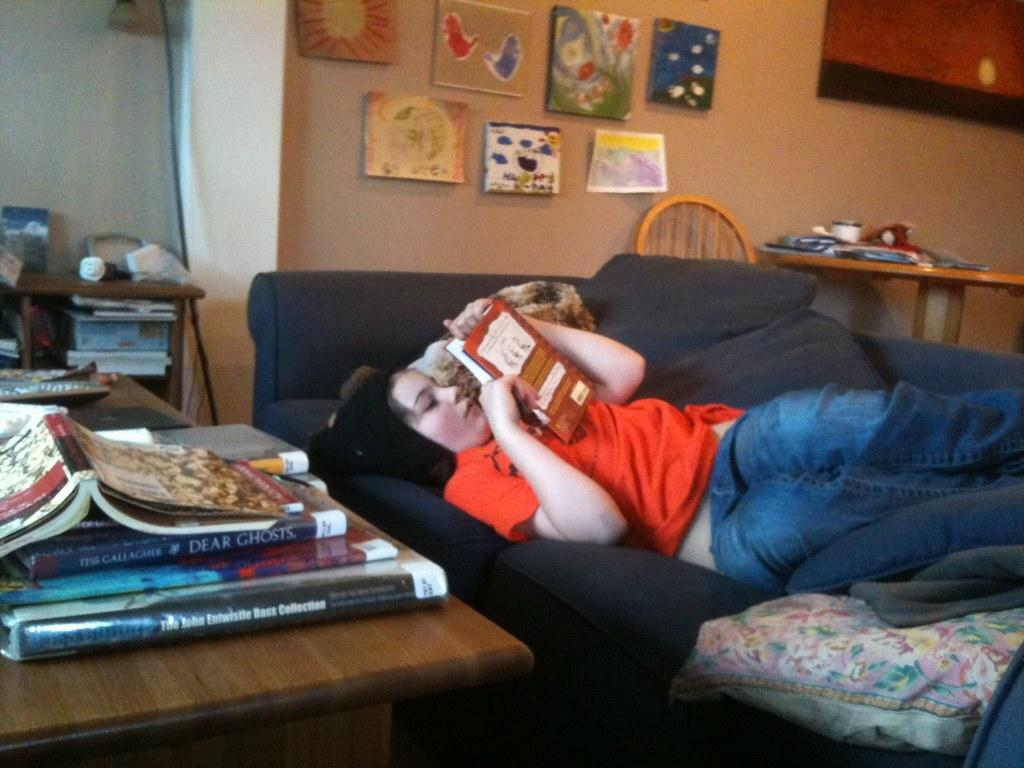<image>
Write a terse but informative summary of the picture. Girl reading a book while a book called "Dear Ghosts" rests on a desk next to her. 